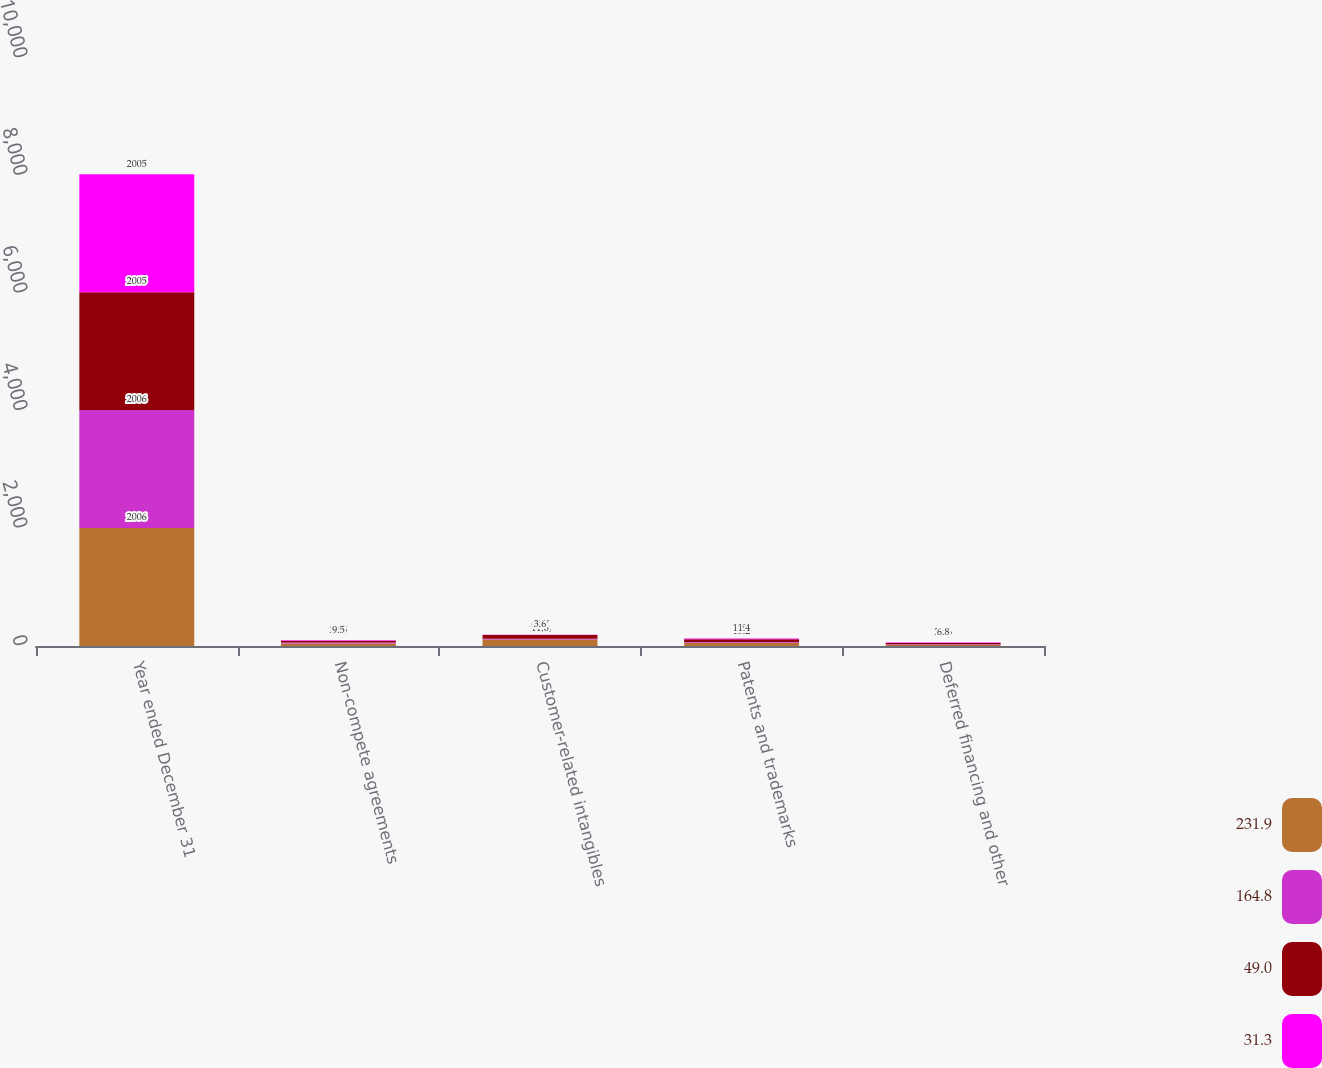<chart> <loc_0><loc_0><loc_500><loc_500><stacked_bar_chart><ecel><fcel>Year ended December 31<fcel>Non-compete agreements<fcel>Customer-related intangibles<fcel>Patents and trademarks<fcel>Deferred financing and other<nl><fcel>231.9<fcel>2006<fcel>44.1<fcel>112.4<fcel>53.5<fcel>21.9<nl><fcel>164.8<fcel>2006<fcel>14.3<fcel>11.6<fcel>15.2<fcel>7.9<nl><fcel>49<fcel>2005<fcel>29.5<fcel>64.7<fcel>48<fcel>22.6<nl><fcel>31.3<fcel>2005<fcel>9.5<fcel>3.6<fcel>11.4<fcel>6.8<nl></chart> 